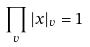Convert formula to latex. <formula><loc_0><loc_0><loc_500><loc_500>\prod _ { v } | x | _ { v } = 1</formula> 